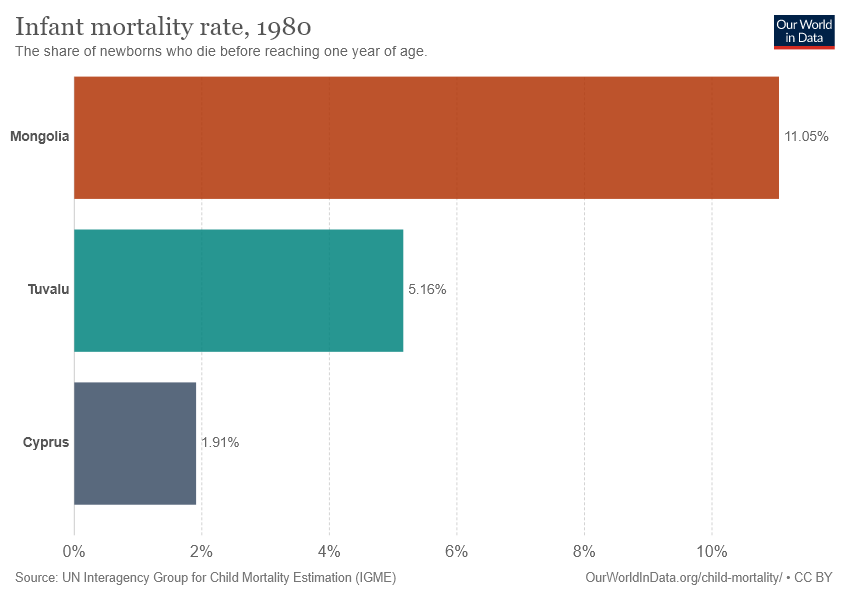Mention a couple of crucial points in this snapshot. The average of the last two bars is 3.535. Three colors are depicted in the bar. 